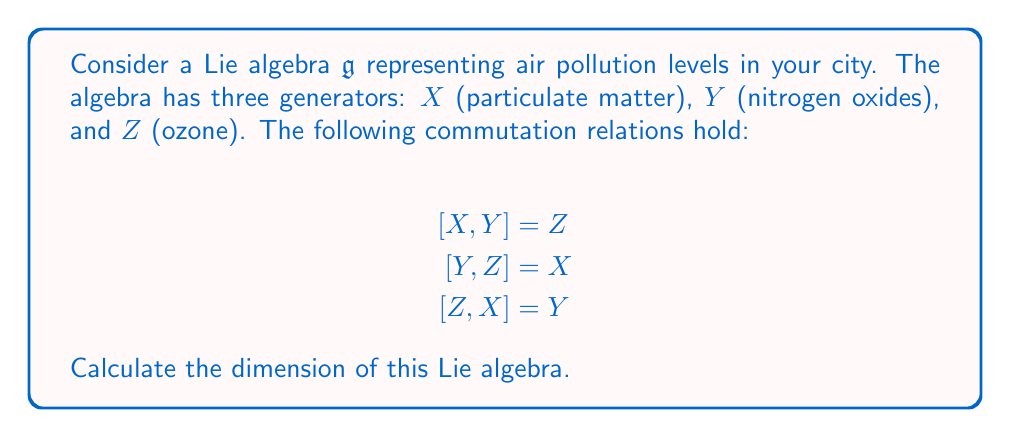Can you solve this math problem? To determine the dimension of a Lie algebra, we need to find the number of linearly independent generators. Let's approach this step-by-step:

1) We are given three generators: $X$, $Y$, and $Z$. These represent different types of air pollutants.

2) The commutation relations show that each generator can be obtained as the commutator of the other two. This suggests that these generators are not trivially related.

3) In a Lie algebra, the dimension is equal to the number of linearly independent generators.

4) To check for linear independence, we can consider a linear combination:

   $aX + bY + cZ = 0$

   where $a$, $b$, and $c$ are scalars.

5) If this equation is only satisfied when $a = b = c = 0$, then $X$, $Y$, and $Z$ are linearly independent.

6) Given the commutation relations, we can see that no non-trivial linear combination of $X$, $Y$, and $Z$ can equal zero. This is because each generator appears uniquely in one of the commutation relations.

7) Therefore, $X$, $Y$, and $Z$ are linearly independent.

8) The dimension of the Lie algebra is equal to the number of linearly independent generators, which in this case is 3.

This Lie algebra is actually isomorphic to $\mathfrak{so}(3)$, the Lie algebra of the special orthogonal group in three dimensions, which is often used in physics to describe rotations in 3D space. In the context of air pollution, this could represent the interrelated nature of different pollutants in the atmosphere.
Answer: The dimension of the Lie algebra is 3. 